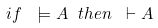Convert formula to latex. <formula><loc_0><loc_0><loc_500><loc_500>i f \ \models A \ t h e n \ \vdash A</formula> 